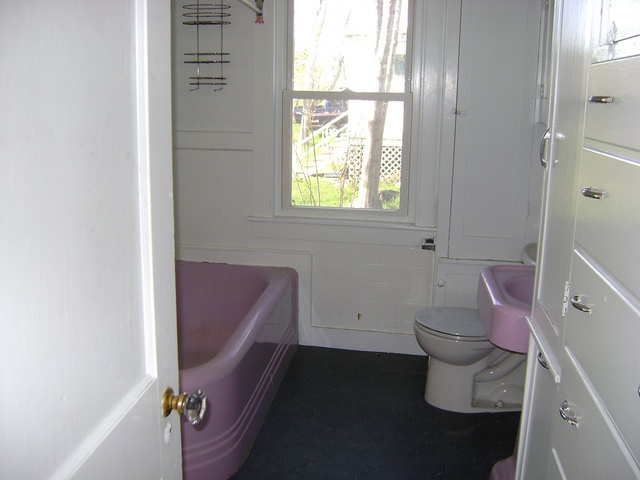Describe the objects in this image and their specific colors. I can see toilet in darkgray, gray, and black tones and sink in darkgray and gray tones in this image. 